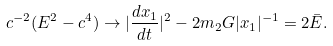<formula> <loc_0><loc_0><loc_500><loc_500>c ^ { - 2 } ( E ^ { 2 } - c ^ { 4 } ) \rightarrow | \frac { d { x } _ { 1 } } { d t } | ^ { 2 } - 2 m _ { 2 } G | { x } _ { 1 } | ^ { - 1 } = 2 \bar { E } .</formula> 